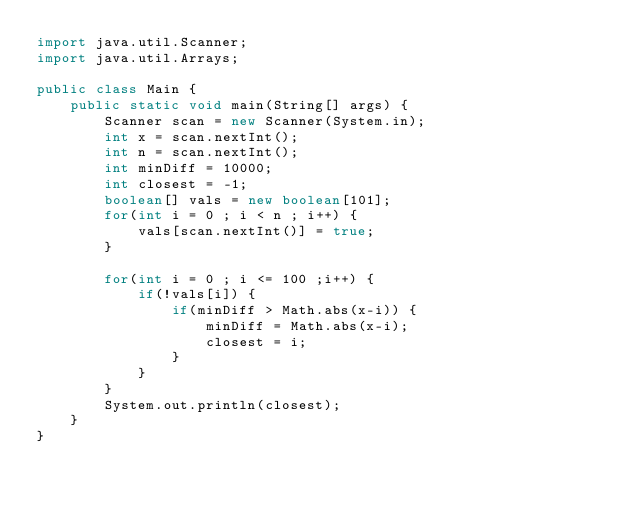Convert code to text. <code><loc_0><loc_0><loc_500><loc_500><_Java_>import java.util.Scanner;
import java.util.Arrays;

public class Main {
    public static void main(String[] args) {
        Scanner scan = new Scanner(System.in);
        int x = scan.nextInt();
        int n = scan.nextInt();
        int minDiff = 10000;
        int closest = -1;
        boolean[] vals = new boolean[101];
        for(int i = 0 ; i < n ; i++) {
            vals[scan.nextInt()] = true;
        }
        
        for(int i = 0 ; i <= 100 ;i++) {
            if(!vals[i]) {
                if(minDiff > Math.abs(x-i)) {
                    minDiff = Math.abs(x-i);
                    closest = i;
                }    
            }
        }
        System.out.println(closest);
    }
}</code> 